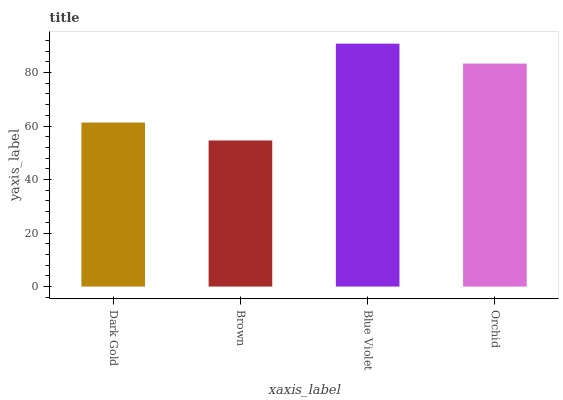Is Blue Violet the minimum?
Answer yes or no. No. Is Brown the maximum?
Answer yes or no. No. Is Blue Violet greater than Brown?
Answer yes or no. Yes. Is Brown less than Blue Violet?
Answer yes or no. Yes. Is Brown greater than Blue Violet?
Answer yes or no. No. Is Blue Violet less than Brown?
Answer yes or no. No. Is Orchid the high median?
Answer yes or no. Yes. Is Dark Gold the low median?
Answer yes or no. Yes. Is Brown the high median?
Answer yes or no. No. Is Orchid the low median?
Answer yes or no. No. 